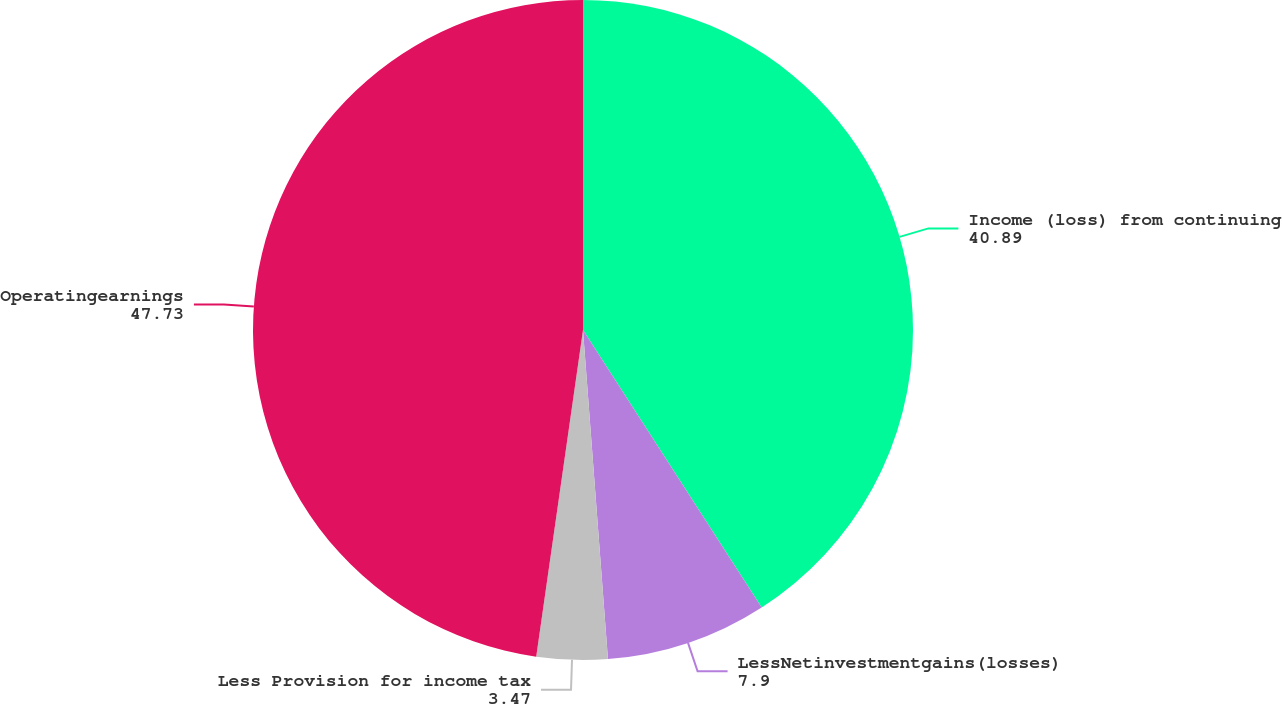<chart> <loc_0><loc_0><loc_500><loc_500><pie_chart><fcel>Income (loss) from continuing<fcel>LessNetinvestmentgains(losses)<fcel>Less Provision for income tax<fcel>Operatingearnings<nl><fcel>40.89%<fcel>7.9%<fcel>3.47%<fcel>47.73%<nl></chart> 